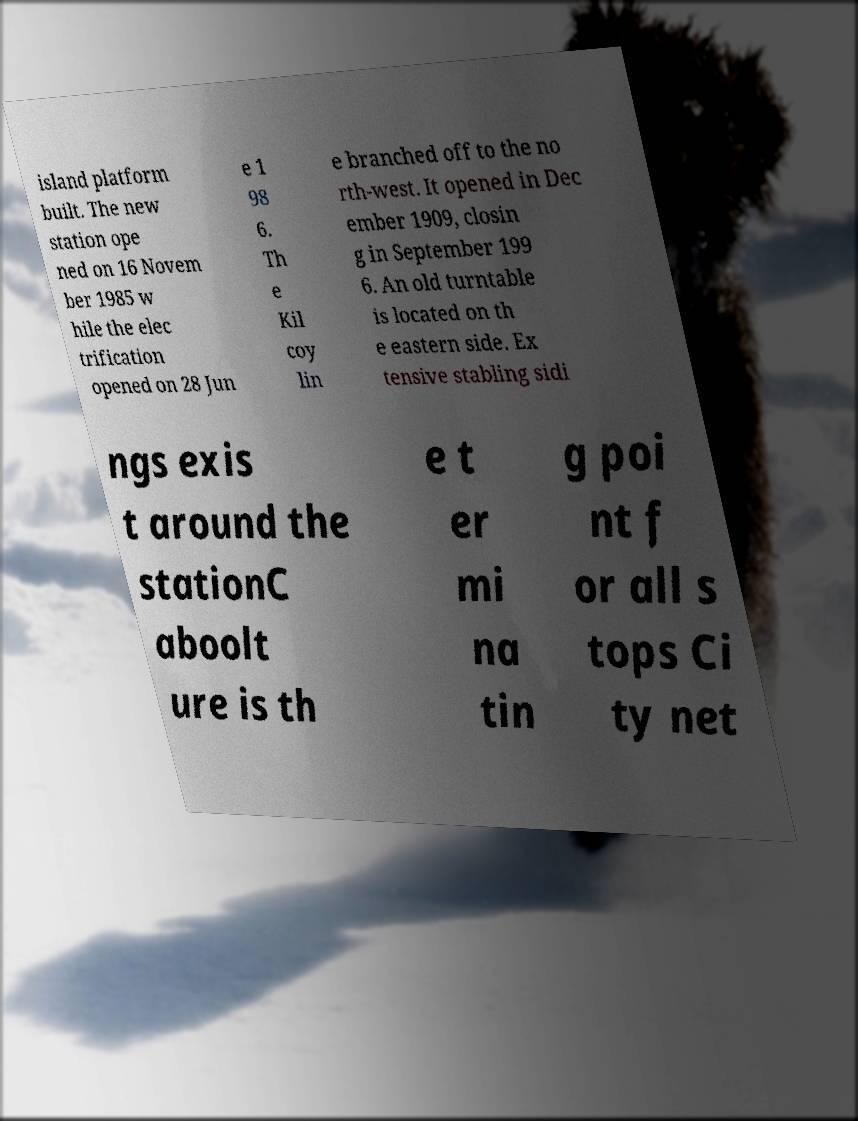For documentation purposes, I need the text within this image transcribed. Could you provide that? island platform built. The new station ope ned on 16 Novem ber 1985 w hile the elec trification opened on 28 Jun e 1 98 6. Th e Kil coy lin e branched off to the no rth-west. It opened in Dec ember 1909, closin g in September 199 6. An old turntable is located on th e eastern side. Ex tensive stabling sidi ngs exis t around the stationC aboolt ure is th e t er mi na tin g poi nt f or all s tops Ci ty net 